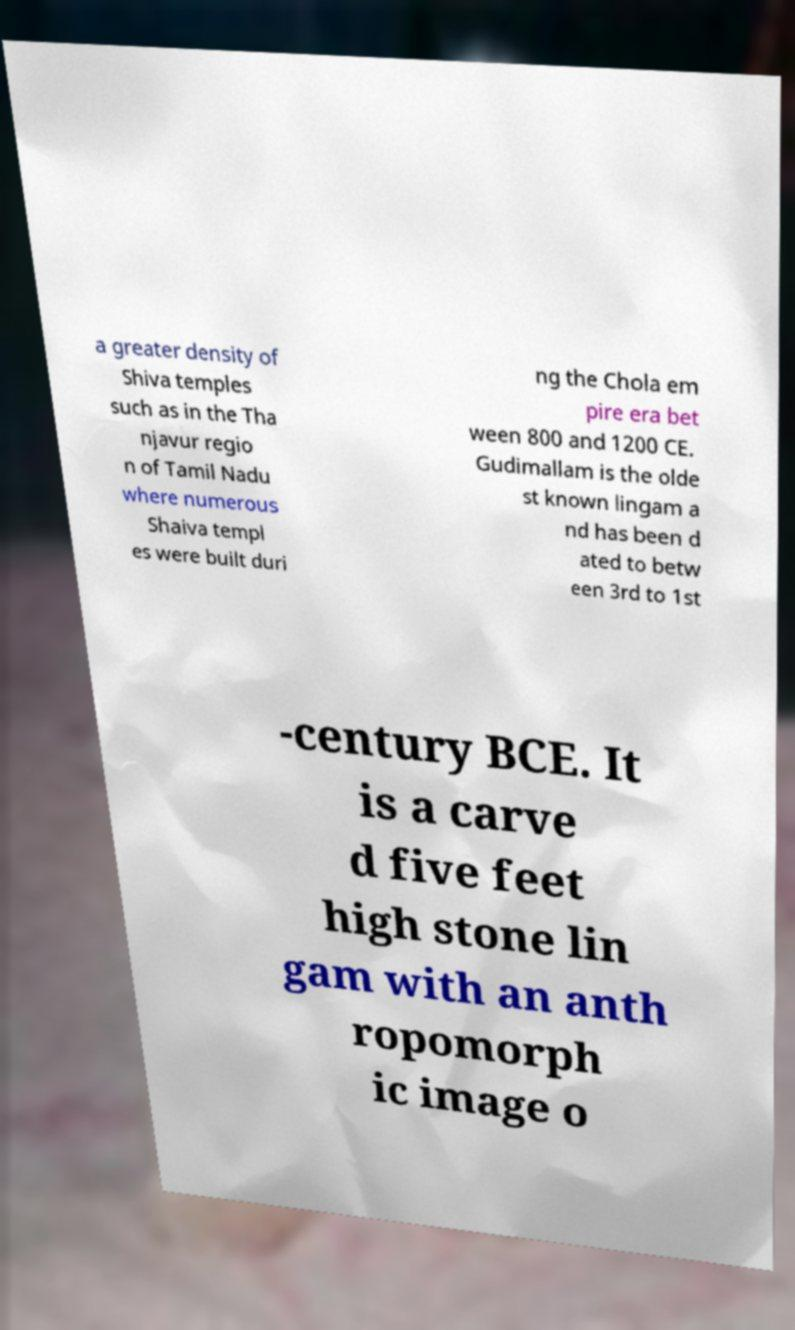Can you read and provide the text displayed in the image?This photo seems to have some interesting text. Can you extract and type it out for me? a greater density of Shiva temples such as in the Tha njavur regio n of Tamil Nadu where numerous Shaiva templ es were built duri ng the Chola em pire era bet ween 800 and 1200 CE. Gudimallam is the olde st known lingam a nd has been d ated to betw een 3rd to 1st -century BCE. It is a carve d five feet high stone lin gam with an anth ropomorph ic image o 